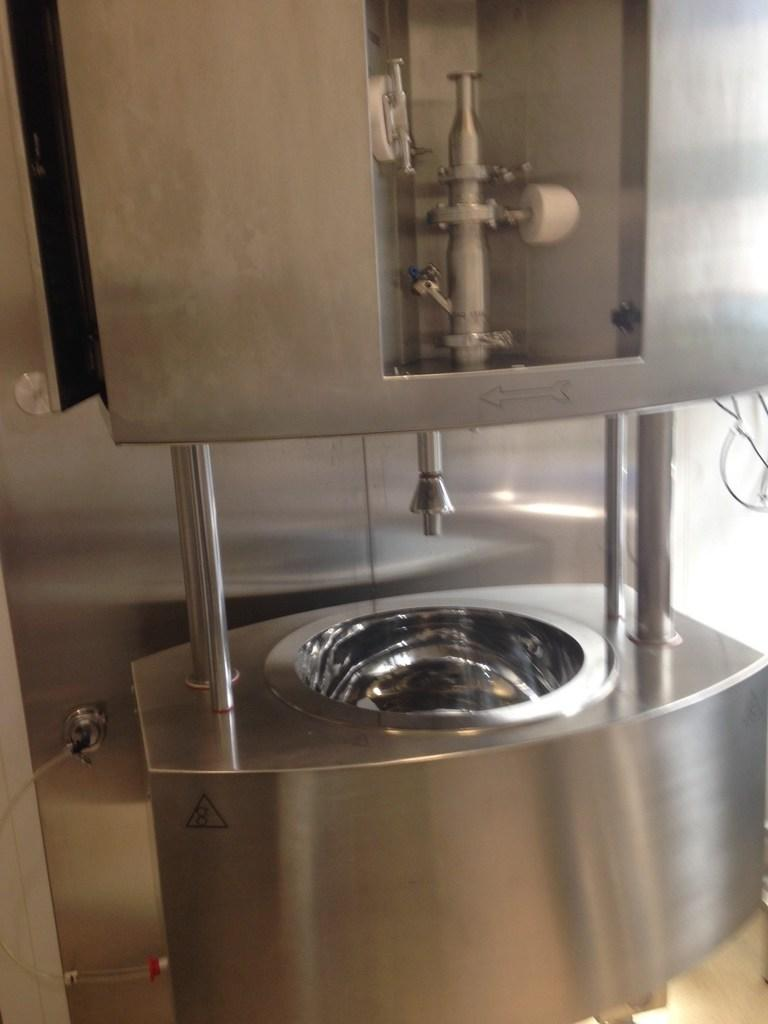What is the main subject in the image? There is a machine in the image. What material is the machine made of? The machine is made up of metal. What is the position of the machine's nose in the image? There is no mention of a nose on the machine in the image, as it is a machine made of metal. What type of juice is being produced by the machine in the image? There is no indication of juice production in the image, as it only features a metal machine. 